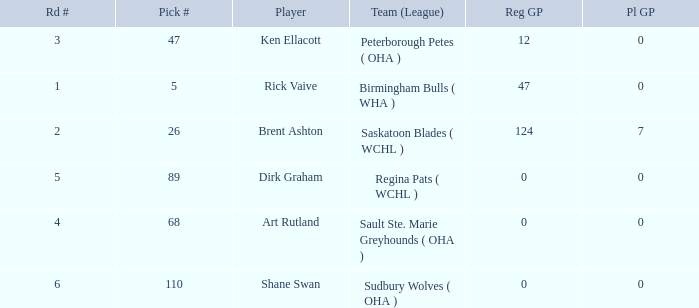How many reg GP for rick vaive in round 1? None. 